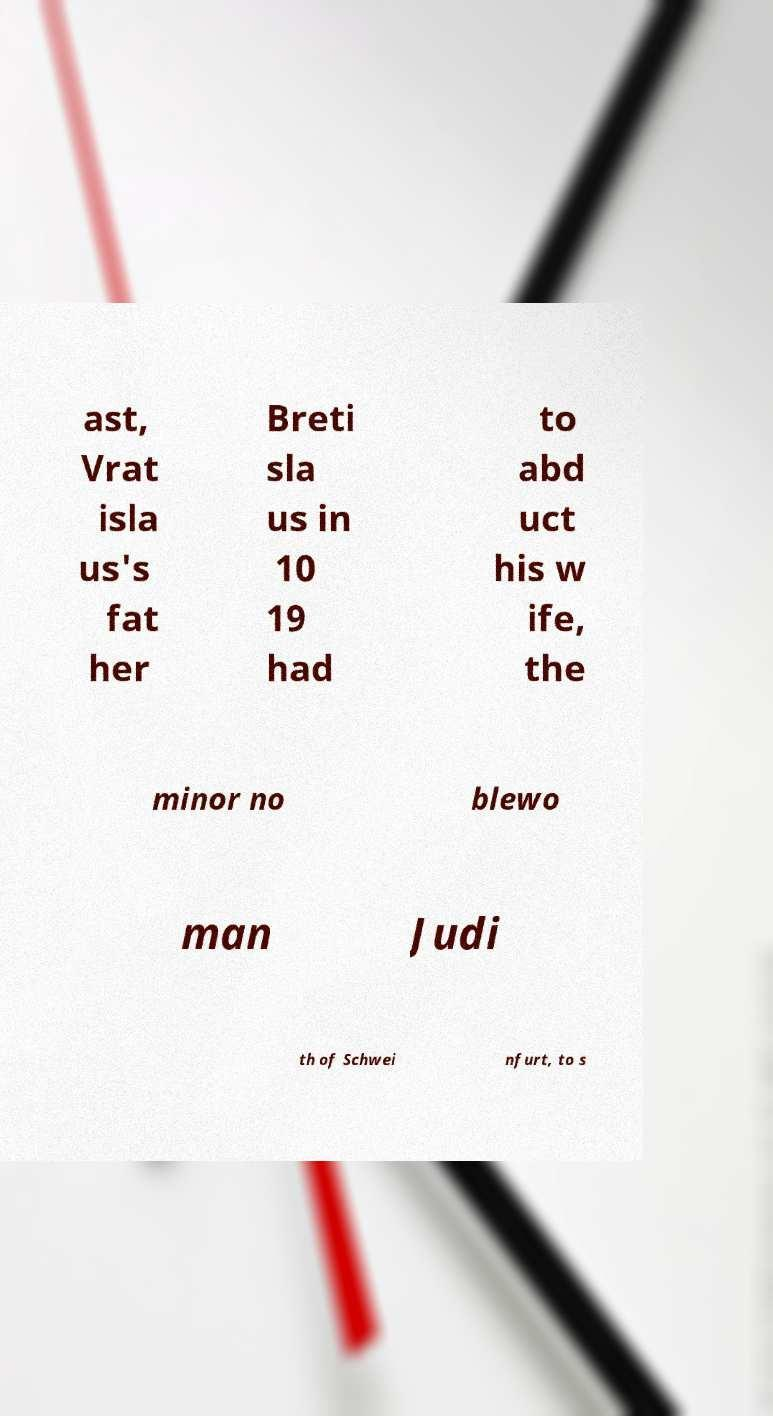There's text embedded in this image that I need extracted. Can you transcribe it verbatim? ast, Vrat isla us's fat her Breti sla us in 10 19 had to abd uct his w ife, the minor no blewo man Judi th of Schwei nfurt, to s 